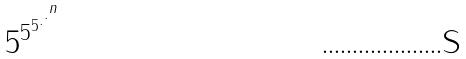<formula> <loc_0><loc_0><loc_500><loc_500>5 ^ { 5 ^ { 5 ^ { . ^ { . ^ { n } } } } }</formula> 